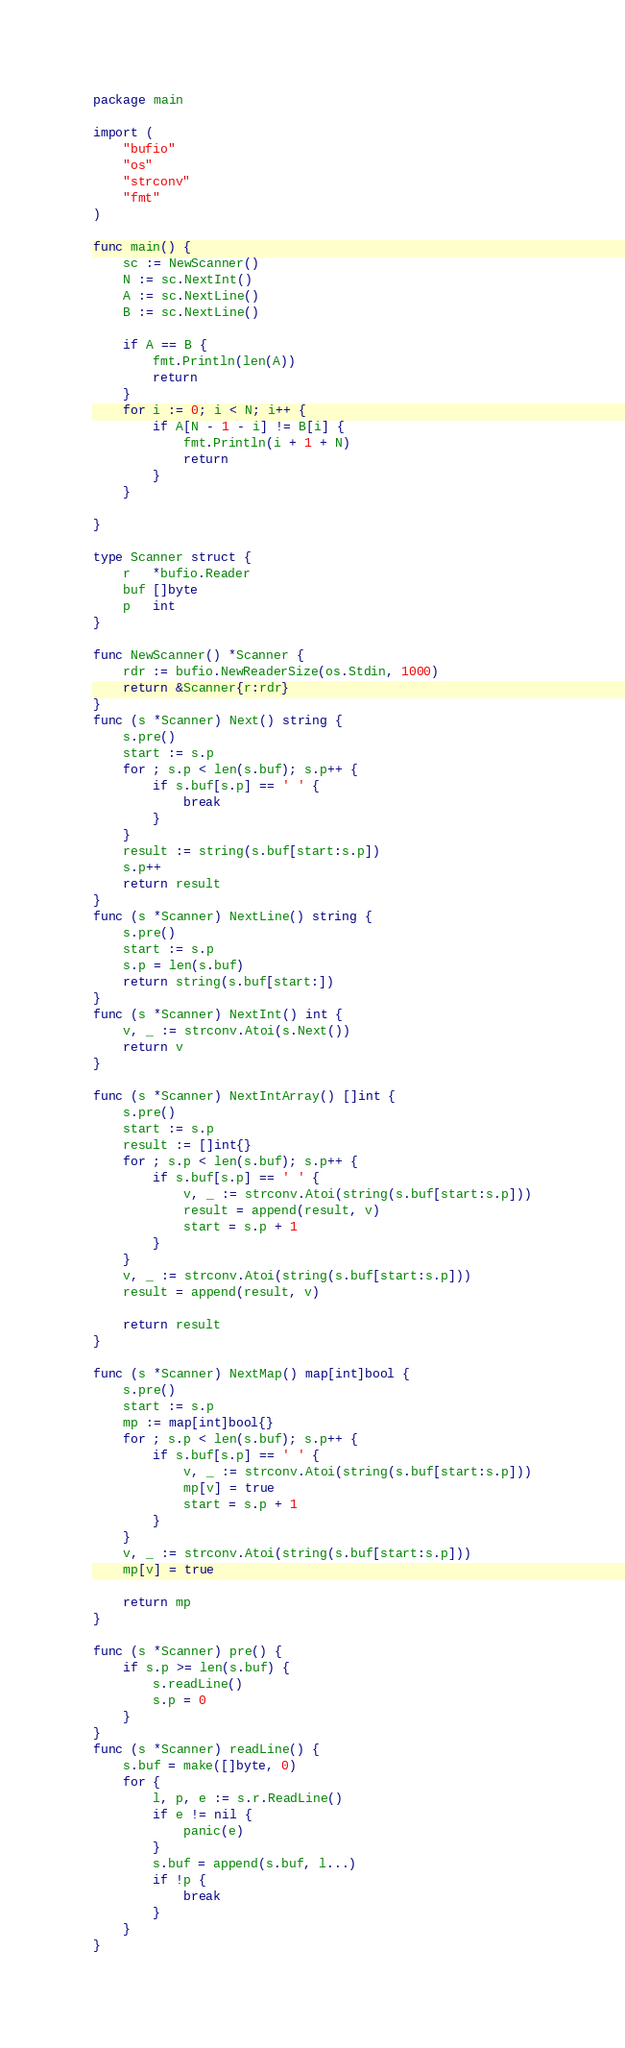Convert code to text. <code><loc_0><loc_0><loc_500><loc_500><_Go_>package main

import (
	"bufio"
	"os"
	"strconv"
	"fmt"
)

func main() {
	sc := NewScanner()
	N := sc.NextInt()
	A := sc.NextLine()
	B := sc.NextLine()

	if A == B {
		fmt.Println(len(A))
		return
	}
	for i := 0; i < N; i++ {
		if A[N - 1 - i] != B[i] {
			fmt.Println(i + 1 + N)
			return
		}
	}

}

type Scanner struct {
	r   *bufio.Reader
	buf []byte
	p   int
}

func NewScanner() *Scanner {
	rdr := bufio.NewReaderSize(os.Stdin, 1000)
	return &Scanner{r:rdr}
}
func (s *Scanner) Next() string {
	s.pre()
	start := s.p
	for ; s.p < len(s.buf); s.p++ {
		if s.buf[s.p] == ' ' {
			break
		}
	}
	result := string(s.buf[start:s.p])
	s.p++
	return result
}
func (s *Scanner) NextLine() string {
	s.pre()
	start := s.p
	s.p = len(s.buf)
	return string(s.buf[start:])
}
func (s *Scanner) NextInt() int {
	v, _ := strconv.Atoi(s.Next())
	return v
}

func (s *Scanner) NextIntArray() []int {
	s.pre()
	start := s.p
	result := []int{}
	for ; s.p < len(s.buf); s.p++ {
		if s.buf[s.p] == ' ' {
			v, _ := strconv.Atoi(string(s.buf[start:s.p]))
			result = append(result, v)
			start = s.p + 1
		}
	}
	v, _ := strconv.Atoi(string(s.buf[start:s.p]))
	result = append(result, v)

	return result
}

func (s *Scanner) NextMap() map[int]bool {
	s.pre()
	start := s.p
	mp := map[int]bool{}
	for ; s.p < len(s.buf); s.p++ {
		if s.buf[s.p] == ' ' {
			v, _ := strconv.Atoi(string(s.buf[start:s.p]))
			mp[v] = true
			start = s.p + 1
		}
	}
	v, _ := strconv.Atoi(string(s.buf[start:s.p]))
	mp[v] = true

	return mp
}

func (s *Scanner) pre() {
	if s.p >= len(s.buf) {
		s.readLine()
		s.p = 0
	}
}
func (s *Scanner) readLine() {
	s.buf = make([]byte, 0)
	for {
		l, p, e := s.r.ReadLine()
		if e != nil {
			panic(e)
		}
		s.buf = append(s.buf, l...)
		if !p {
			break
		}
	}
}
</code> 